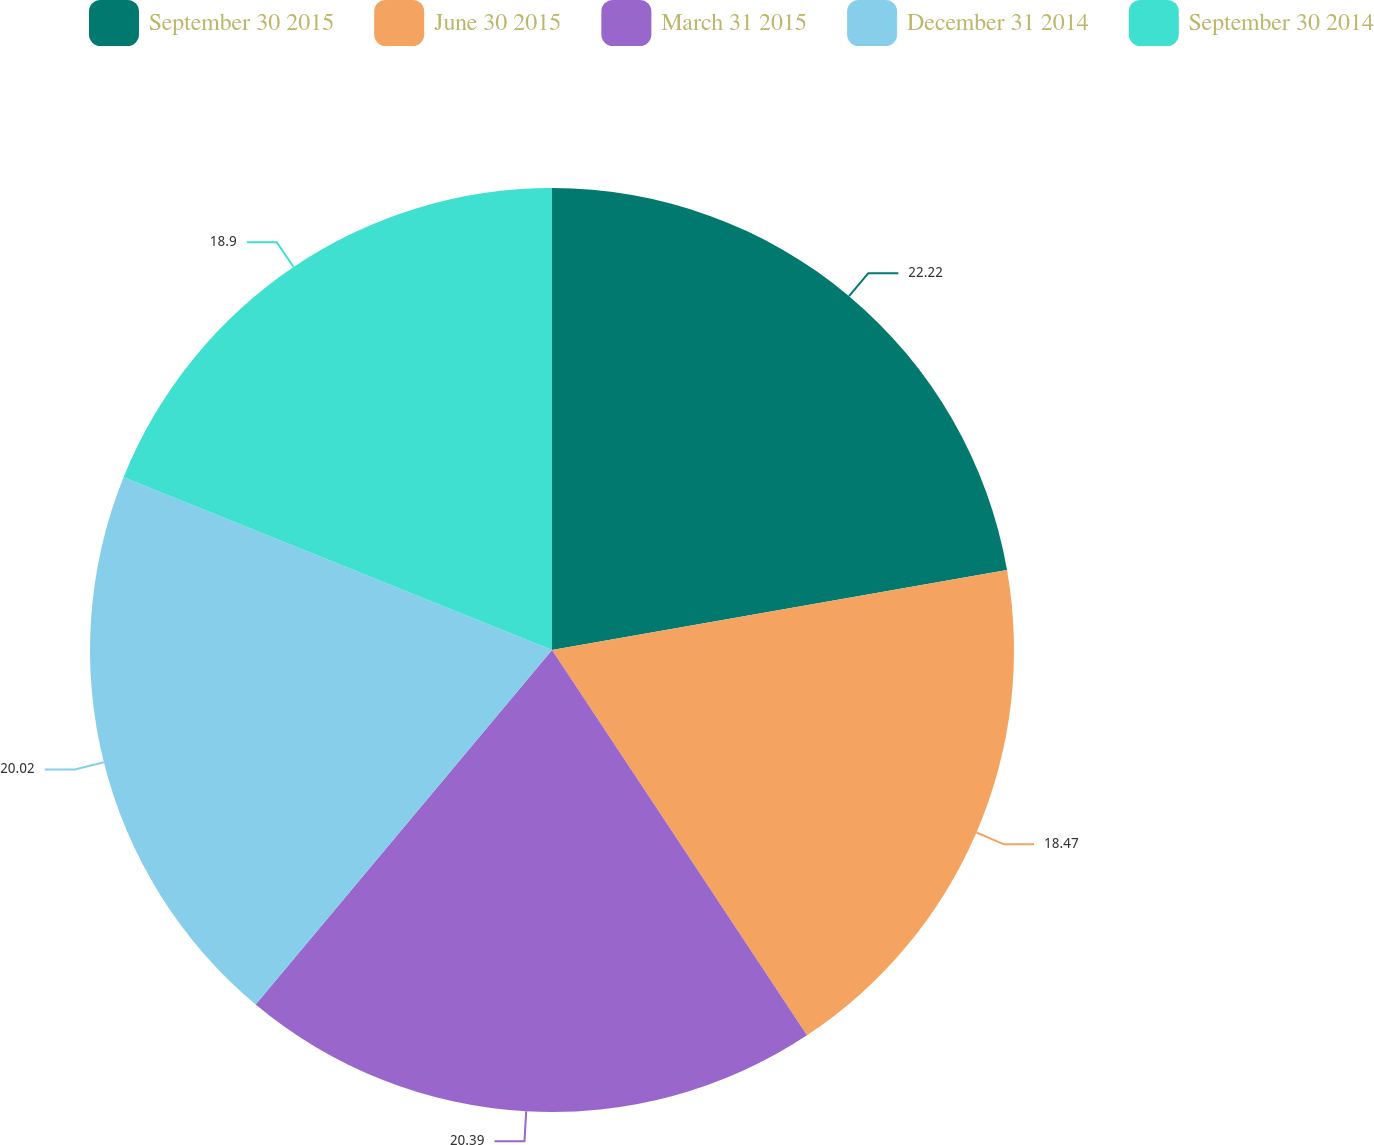<chart> <loc_0><loc_0><loc_500><loc_500><pie_chart><fcel>September 30 2015<fcel>June 30 2015<fcel>March 31 2015<fcel>December 31 2014<fcel>September 30 2014<nl><fcel>22.23%<fcel>18.47%<fcel>20.39%<fcel>20.02%<fcel>18.9%<nl></chart> 